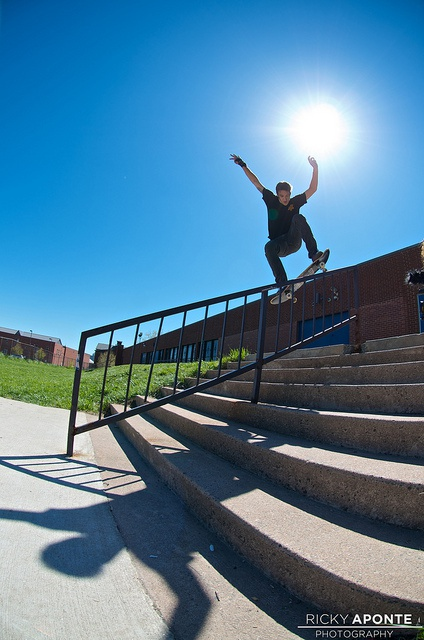Describe the objects in this image and their specific colors. I can see people in blue, black, and gray tones and skateboard in blue, gray, and black tones in this image. 